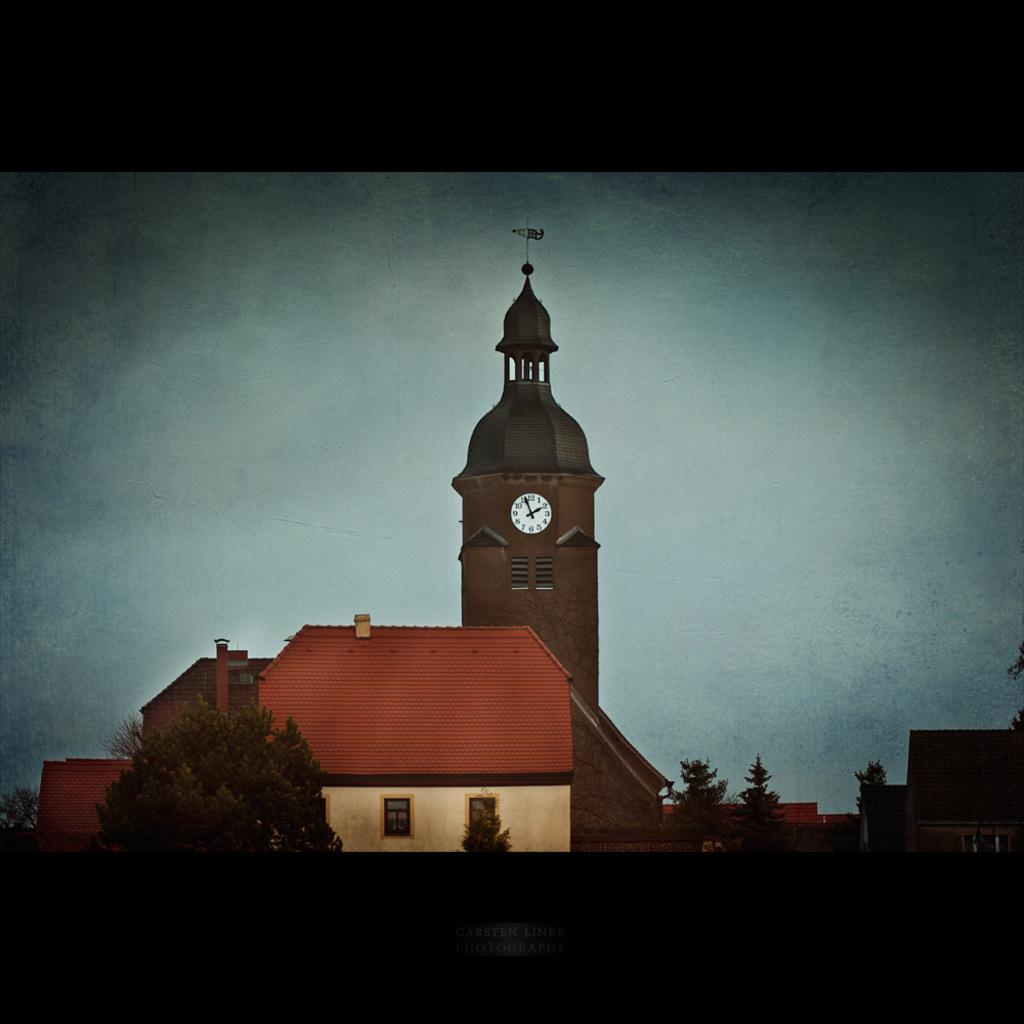What structures are located in the center of the image? There are buildings and a tower in the center of the image. What type of vegetation is at the bottom of the image? There are trees at the bottom of the image. What can be seen in the background of the image? The sky is visible in the background of the image. What book is the beetle reading in the image? There is no beetle or book present in the image. What type of cover is on the trees at the bottom of the image? There is no mention of a cover on the trees in the image; they are simply trees. 